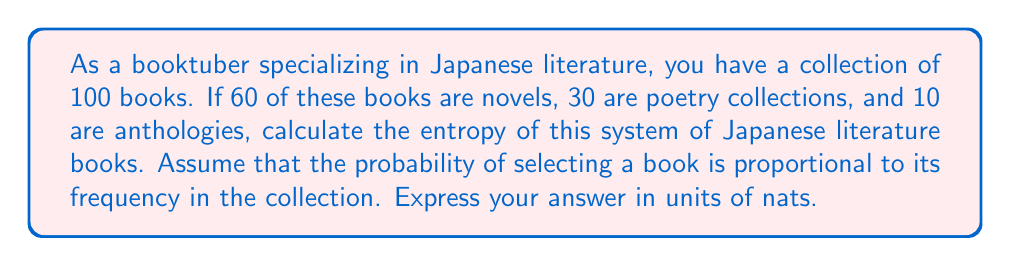Can you answer this question? To calculate the entropy of this system, we'll use the formula for Shannon entropy:

$$S = -\sum_{i} p_i \ln(p_i)$$

Where $p_i$ is the probability of selecting a book from category $i$.

Step 1: Calculate the probabilities for each category
- Novels: $p_1 = 60/100 = 0.6$
- Poetry collections: $p_2 = 30/100 = 0.3$
- Anthologies: $p_3 = 10/100 = 0.1$

Step 2: Calculate each term in the sum
- For novels: $-0.6 \ln(0.6) = 0.3065$
- For poetry collections: $-0.3 \ln(0.3) = 0.3611$
- For anthologies: $-0.1 \ln(0.1) = 0.2303$

Step 3: Sum all terms
$$S = 0.3065 + 0.3611 + 0.2303 = 0.8979$$

Therefore, the entropy of the system is approximately 0.8979 nats.
Answer: 0.8979 nats 